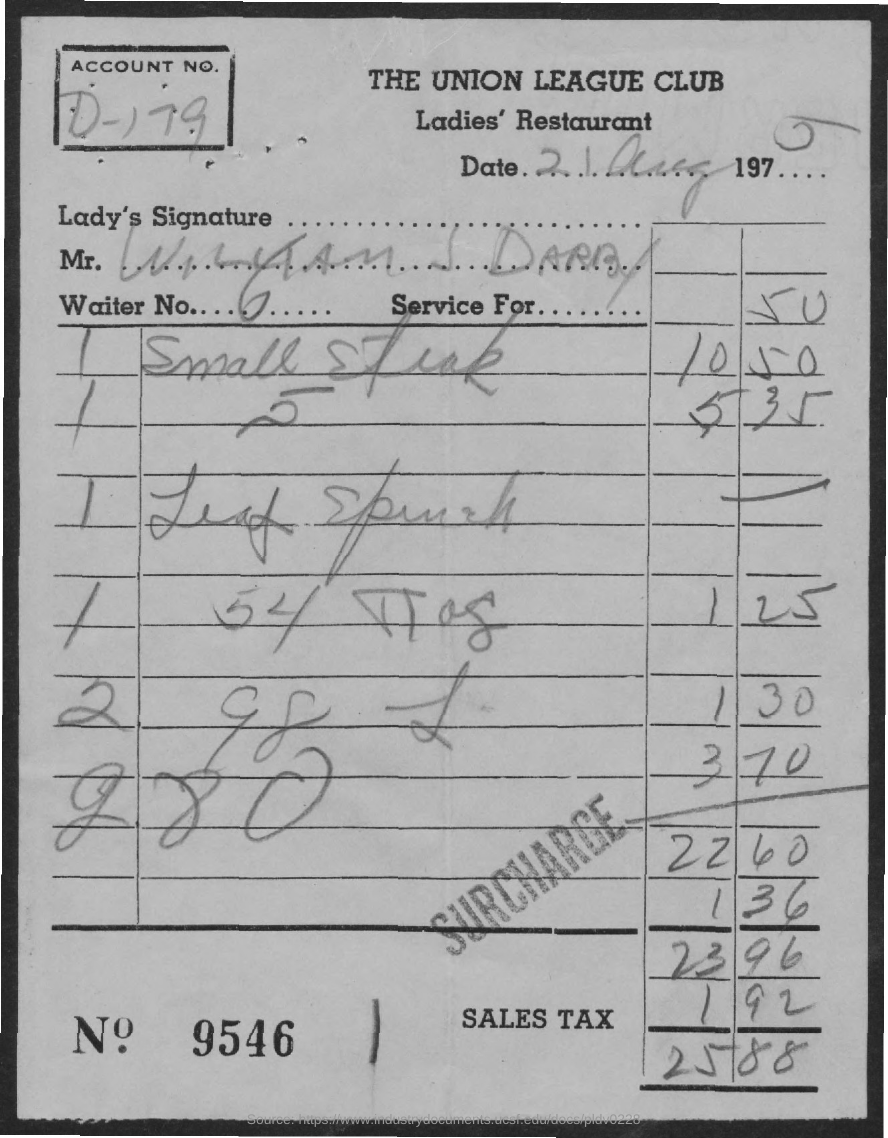Point out several critical features in this image. The sales tax charged was 1.92... The total amount is 25.88. The account number is D-179. The date on the bill is August 21, 1975. What is the bill number?" could be rephrased as "What is the bill number? 